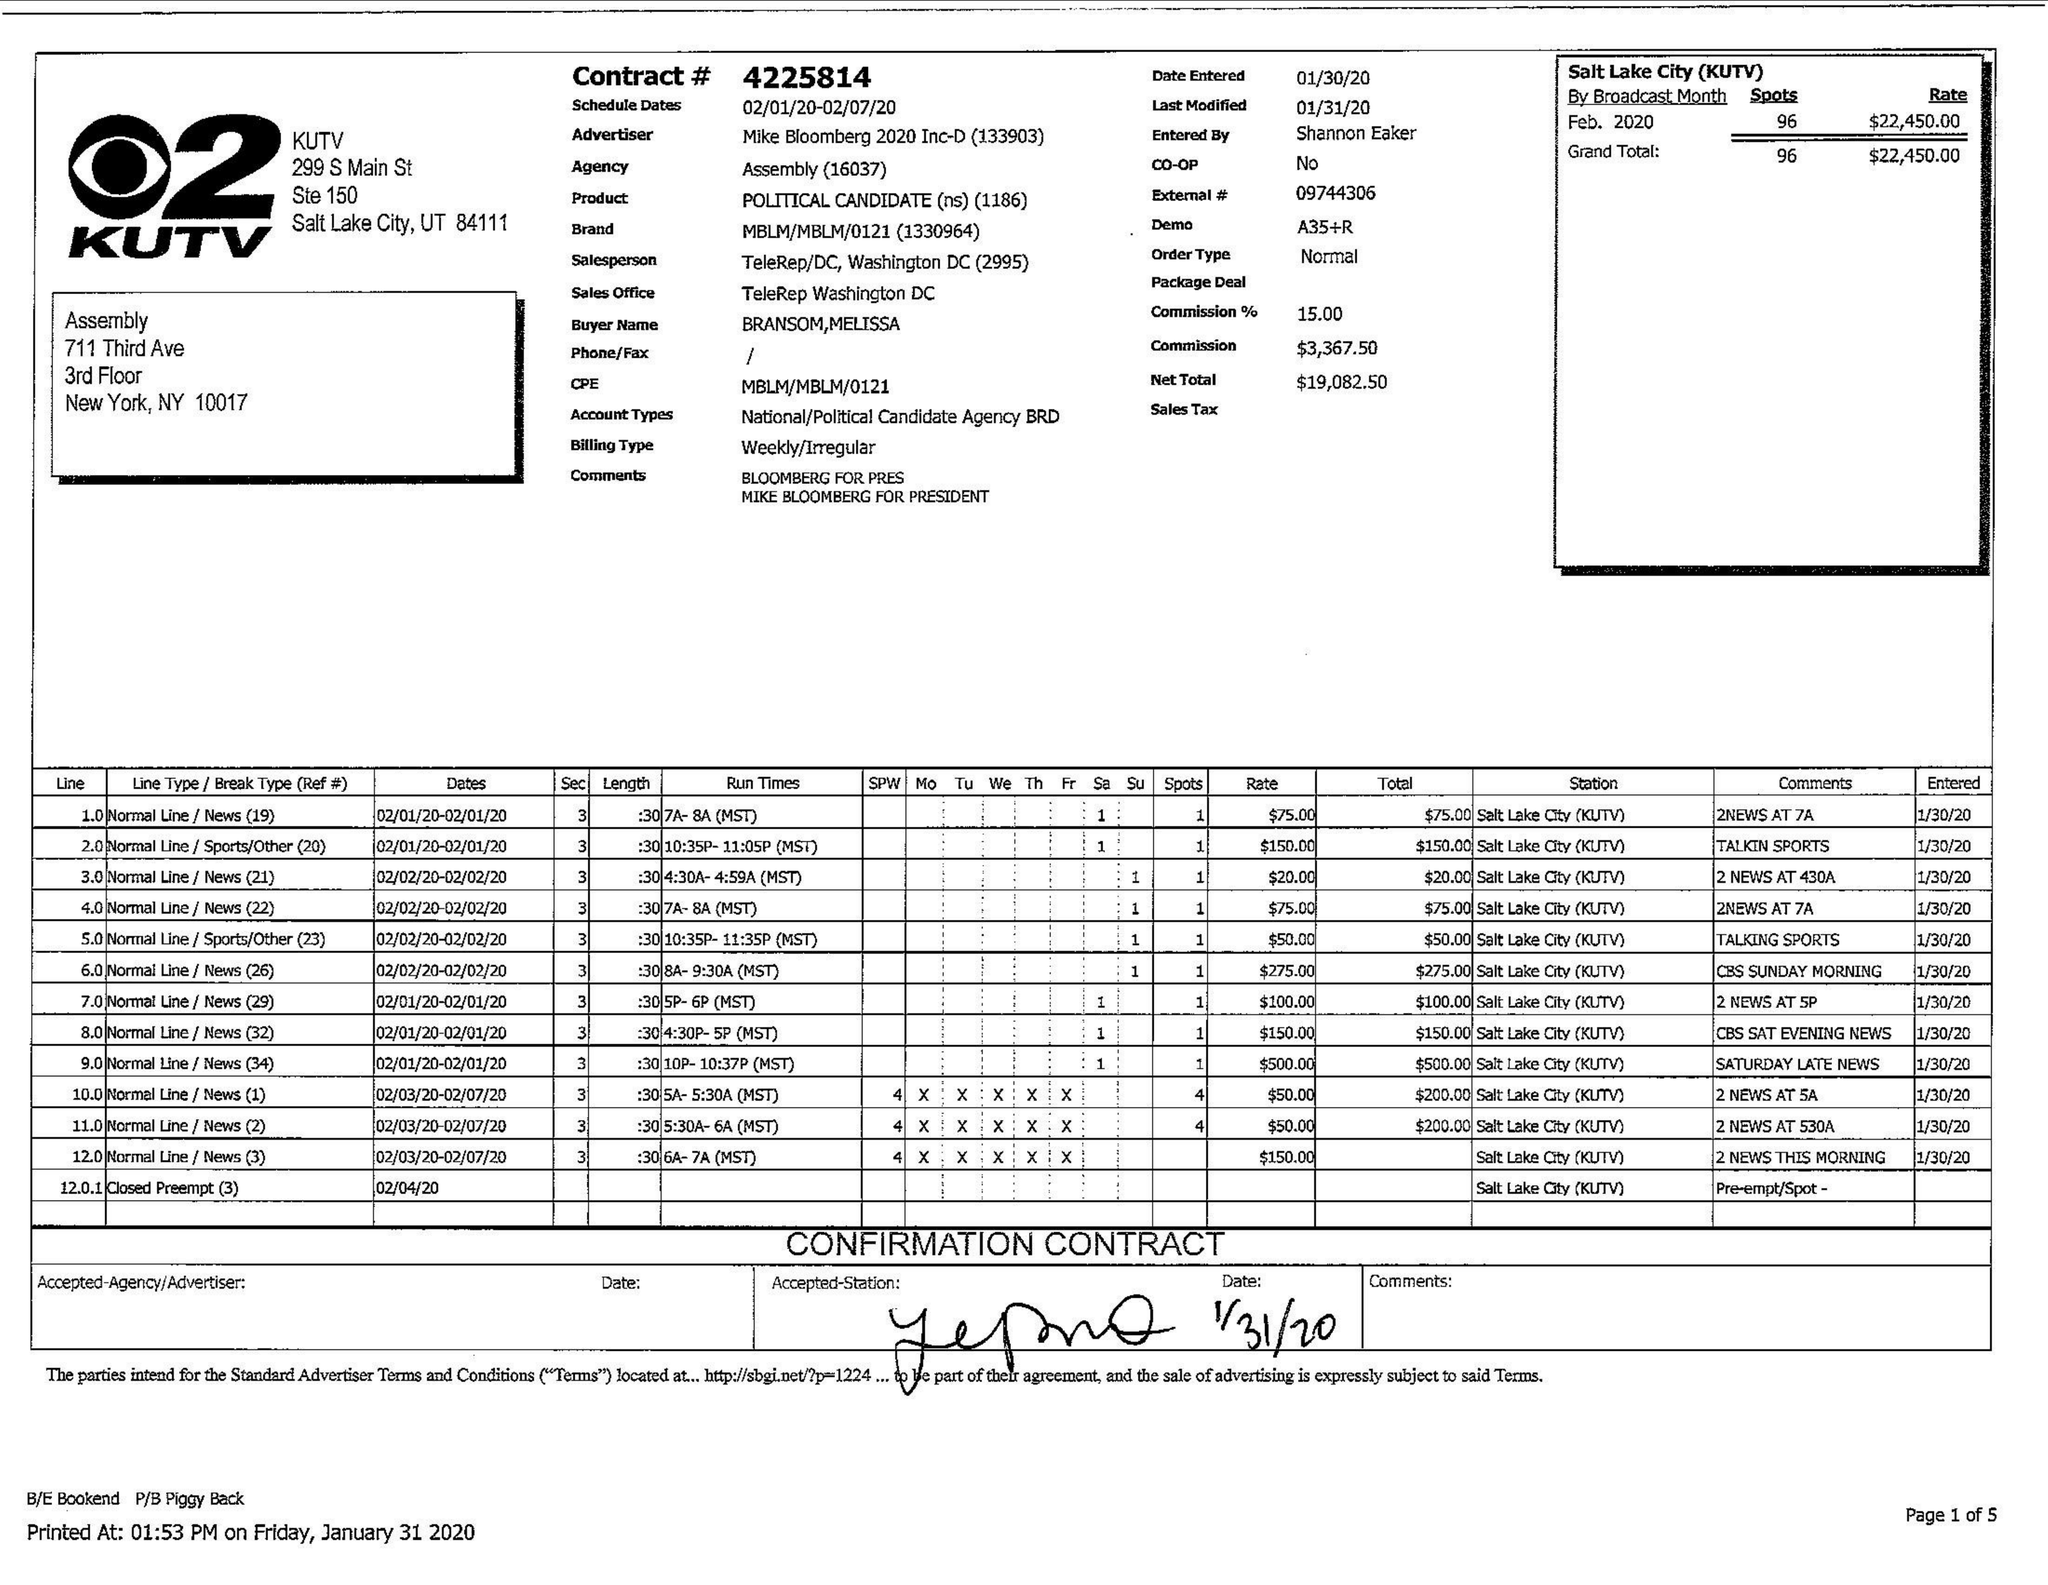What is the value for the flight_from?
Answer the question using a single word or phrase. 02/01/20 